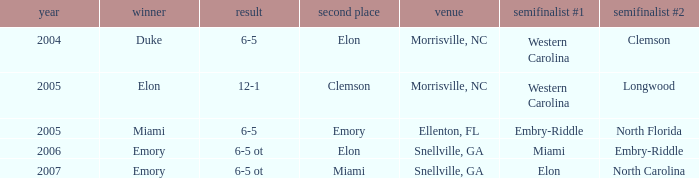Which team was the second semi finalist in 2007? North Carolina. 